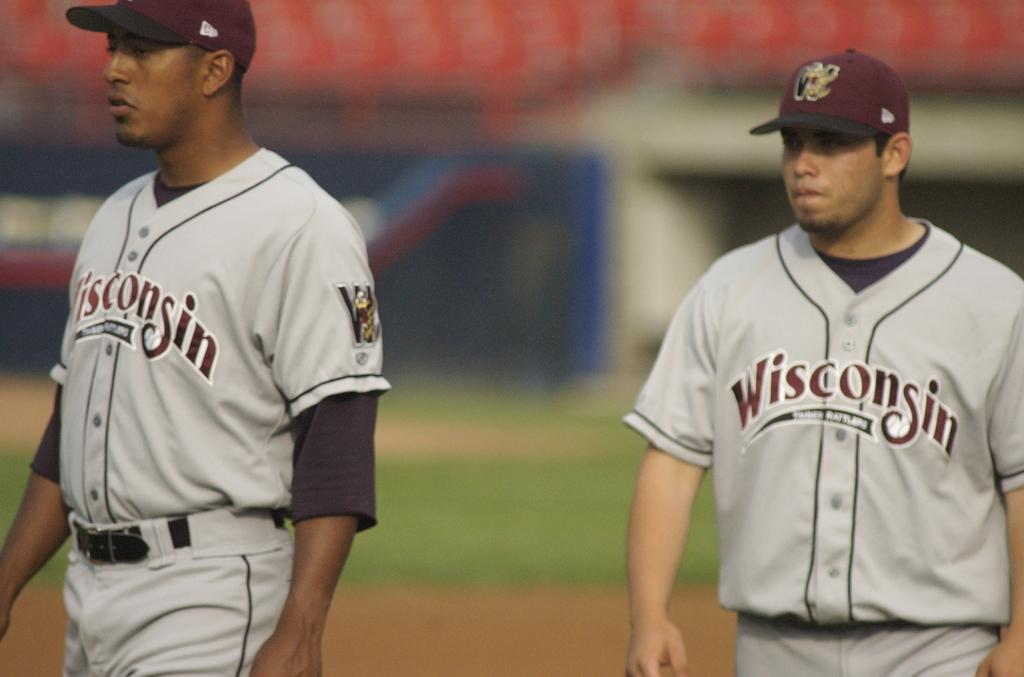<image>
Create a compact narrative representing the image presented. Two baseball players wearing Wisconsin uniforms are standing next to each other. 